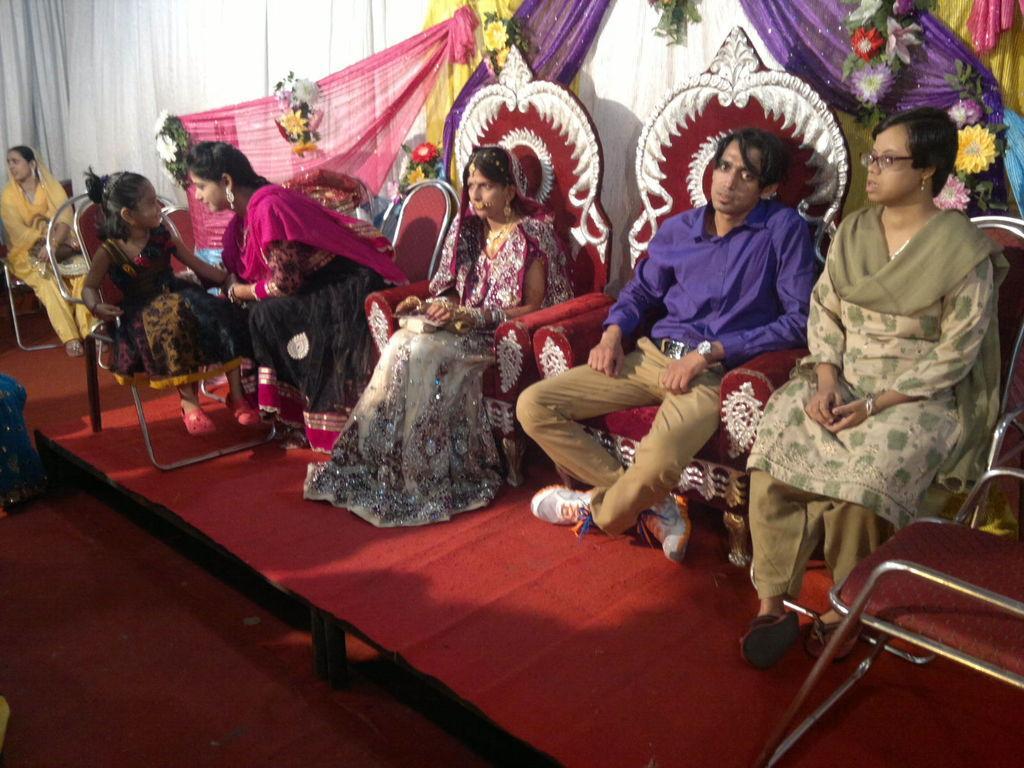Describe this image in one or two sentences. In this image we can see a few people sitting on the chairs and in the background, we can see some decoration with flowers and curtains. 